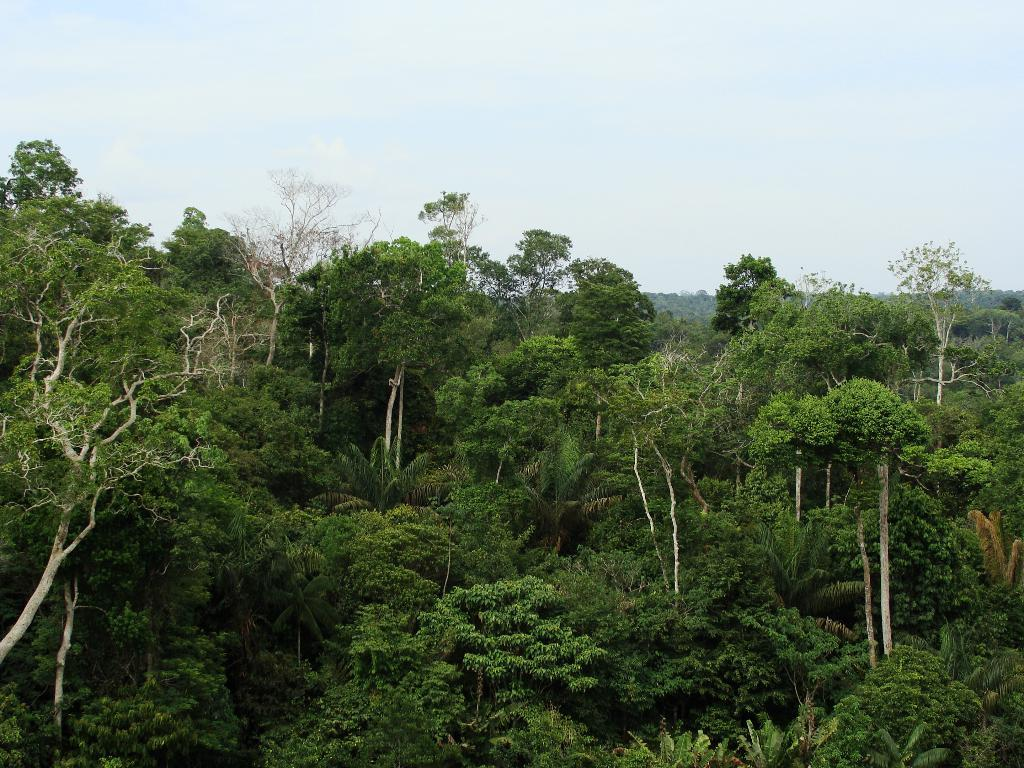What type of vegetation can be seen in the image? There are trees in the image. What is visible at the top of the image? The sky is visible at the top of the image. Who is the manager of the trees in the image? There is no manager present in the image, as trees do not have managers. What type of lock can be seen securing the front of the image? There is no lock present in the image, and the concept of a "front" of the image is not applicable, as it is a two-dimensional representation. 